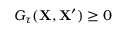Convert formula to latex. <formula><loc_0><loc_0><loc_500><loc_500>G _ { \tau } ( X , X ^ { \prime } ) \geq 0</formula> 